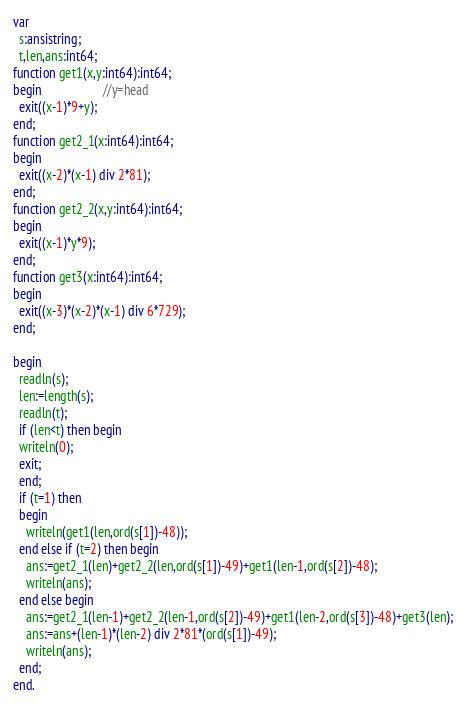Convert code to text. <code><loc_0><loc_0><loc_500><loc_500><_Pascal_>var
  s:ansistring;
  t,len,ans:int64;
function get1(x,y:int64):int64;
begin                   //y=head
  exit((x-1)*9+y);
end;
function get2_1(x:int64):int64;
begin
  exit((x-2)*(x-1) div 2*81);
end;
function get2_2(x,y:int64):int64;
begin
  exit((x-1)*y*9);
end;
function get3(x:int64):int64;
begin
  exit((x-3)*(x-2)*(x-1) div 6*729);
end;

begin
  readln(s);
  len:=length(s);
  readln(t);
  if (len<t) then begin
  writeln(0);
  exit;
  end;
  if (t=1) then
  begin
    writeln(get1(len,ord(s[1])-48));
  end else if (t=2) then begin
    ans:=get2_1(len)+get2_2(len,ord(s[1])-49)+get1(len-1,ord(s[2])-48);
    writeln(ans);
  end else begin
    ans:=get2_1(len-1)+get2_2(len-1,ord(s[2])-49)+get1(len-2,ord(s[3])-48)+get3(len);
    ans:=ans+(len-1)*(len-2) div 2*81*(ord(s[1])-49);
    writeln(ans);
  end;
end.</code> 